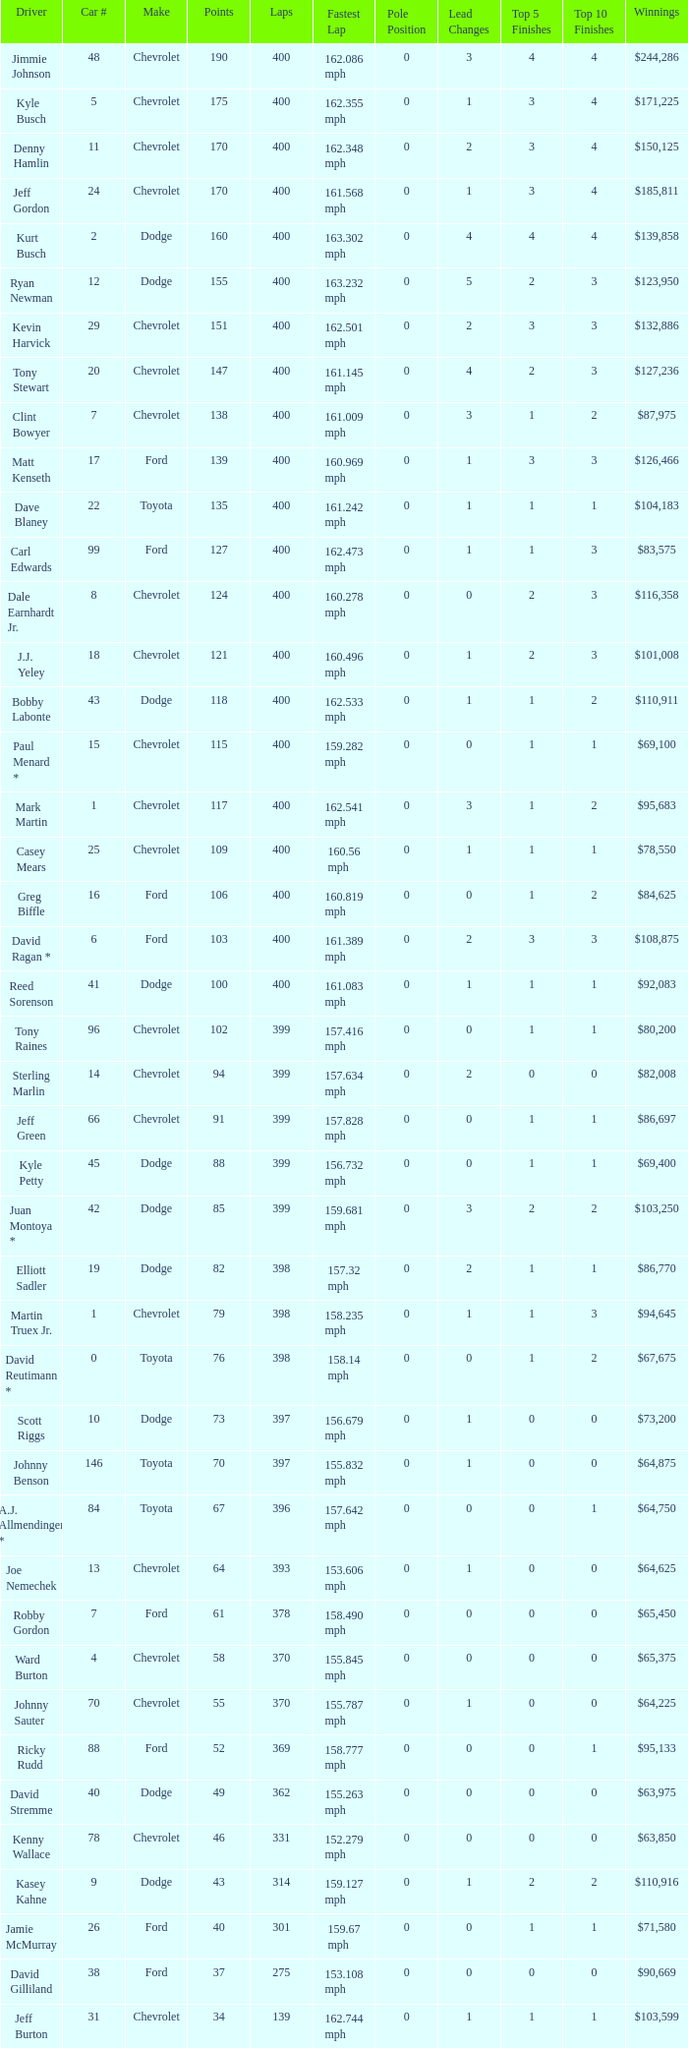What is the make of car 31? Chevrolet. 